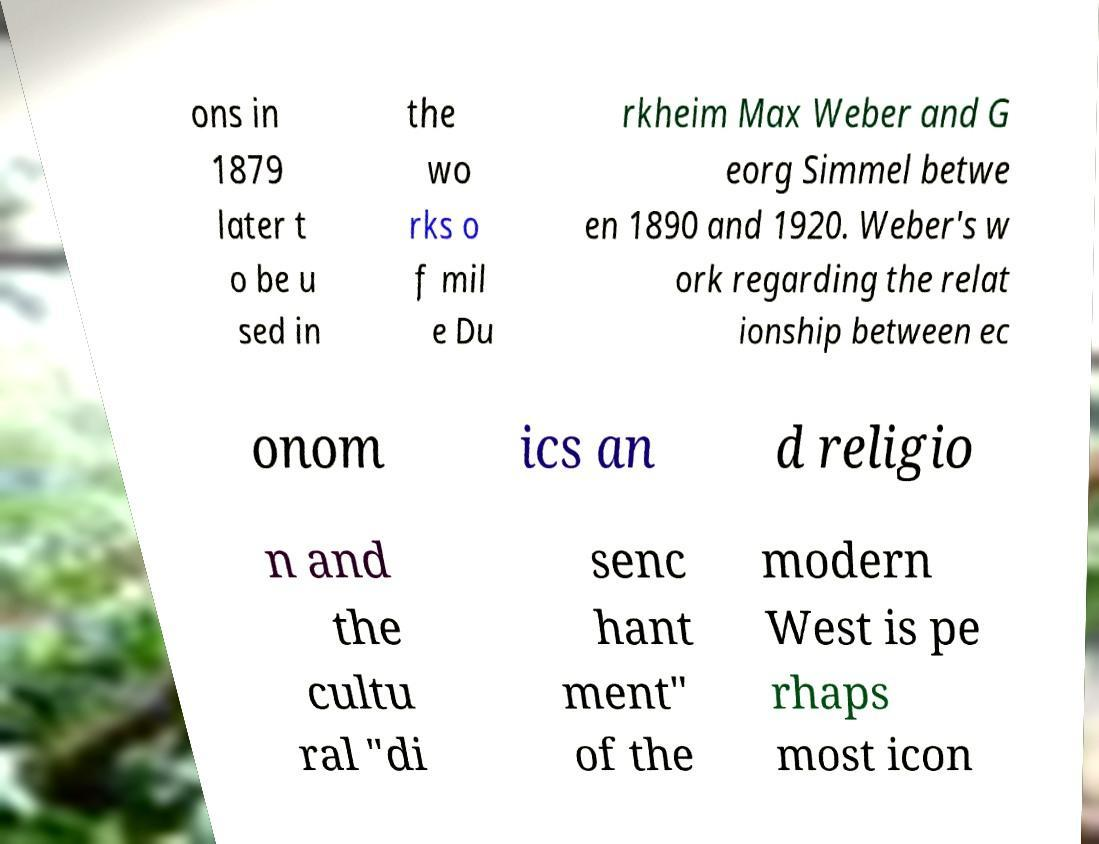There's text embedded in this image that I need extracted. Can you transcribe it verbatim? ons in 1879 later t o be u sed in the wo rks o f mil e Du rkheim Max Weber and G eorg Simmel betwe en 1890 and 1920. Weber's w ork regarding the relat ionship between ec onom ics an d religio n and the cultu ral "di senc hant ment" of the modern West is pe rhaps most icon 